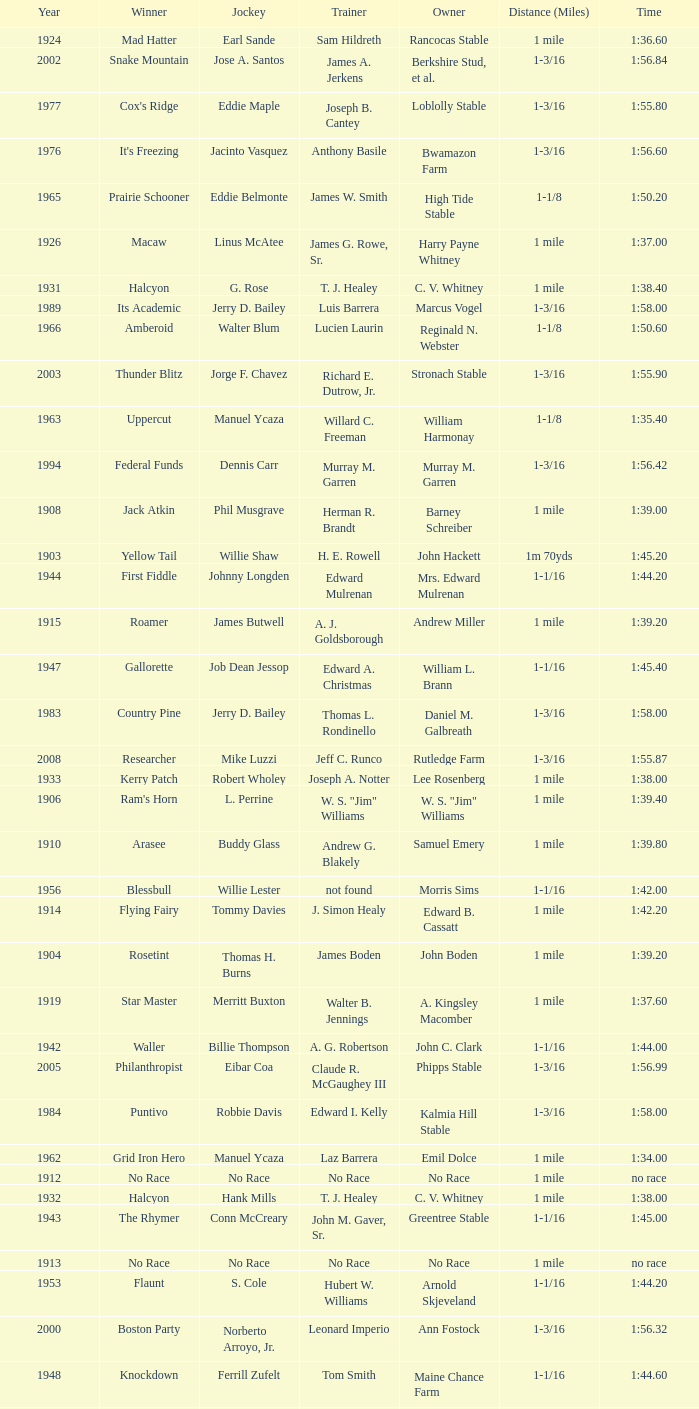Give me the full table as a dictionary. {'header': ['Year', 'Winner', 'Jockey', 'Trainer', 'Owner', 'Distance (Miles)', 'Time'], 'rows': [['1924', 'Mad Hatter', 'Earl Sande', 'Sam Hildreth', 'Rancocas Stable', '1 mile', '1:36.60'], ['2002', 'Snake Mountain', 'Jose A. Santos', 'James A. Jerkens', 'Berkshire Stud, et al.', '1-3/16', '1:56.84'], ['1977', "Cox's Ridge", 'Eddie Maple', 'Joseph B. Cantey', 'Loblolly Stable', '1-3/16', '1:55.80'], ['1976', "It's Freezing", 'Jacinto Vasquez', 'Anthony Basile', 'Bwamazon Farm', '1-3/16', '1:56.60'], ['1965', 'Prairie Schooner', 'Eddie Belmonte', 'James W. Smith', 'High Tide Stable', '1-1/8', '1:50.20'], ['1926', 'Macaw', 'Linus McAtee', 'James G. Rowe, Sr.', 'Harry Payne Whitney', '1 mile', '1:37.00'], ['1931', 'Halcyon', 'G. Rose', 'T. J. Healey', 'C. V. Whitney', '1 mile', '1:38.40'], ['1989', 'Its Academic', 'Jerry D. Bailey', 'Luis Barrera', 'Marcus Vogel', '1-3/16', '1:58.00'], ['1966', 'Amberoid', 'Walter Blum', 'Lucien Laurin', 'Reginald N. Webster', '1-1/8', '1:50.60'], ['2003', 'Thunder Blitz', 'Jorge F. Chavez', 'Richard E. Dutrow, Jr.', 'Stronach Stable', '1-3/16', '1:55.90'], ['1963', 'Uppercut', 'Manuel Ycaza', 'Willard C. Freeman', 'William Harmonay', '1-1/8', '1:35.40'], ['1994', 'Federal Funds', 'Dennis Carr', 'Murray M. Garren', 'Murray M. Garren', '1-3/16', '1:56.42'], ['1908', 'Jack Atkin', 'Phil Musgrave', 'Herman R. Brandt', 'Barney Schreiber', '1 mile', '1:39.00'], ['1903', 'Yellow Tail', 'Willie Shaw', 'H. E. Rowell', 'John Hackett', '1m 70yds', '1:45.20'], ['1944', 'First Fiddle', 'Johnny Longden', 'Edward Mulrenan', 'Mrs. Edward Mulrenan', '1-1/16', '1:44.20'], ['1915', 'Roamer', 'James Butwell', 'A. J. Goldsborough', 'Andrew Miller', '1 mile', '1:39.20'], ['1947', 'Gallorette', 'Job Dean Jessop', 'Edward A. Christmas', 'William L. Brann', '1-1/16', '1:45.40'], ['1983', 'Country Pine', 'Jerry D. Bailey', 'Thomas L. Rondinello', 'Daniel M. Galbreath', '1-3/16', '1:58.00'], ['2008', 'Researcher', 'Mike Luzzi', 'Jeff C. Runco', 'Rutledge Farm', '1-3/16', '1:55.87'], ['1933', 'Kerry Patch', 'Robert Wholey', 'Joseph A. Notter', 'Lee Rosenberg', '1 mile', '1:38.00'], ['1906', "Ram's Horn", 'L. Perrine', 'W. S. "Jim" Williams', 'W. S. "Jim" Williams', '1 mile', '1:39.40'], ['1910', 'Arasee', 'Buddy Glass', 'Andrew G. Blakely', 'Samuel Emery', '1 mile', '1:39.80'], ['1956', 'Blessbull', 'Willie Lester', 'not found', 'Morris Sims', '1-1/16', '1:42.00'], ['1914', 'Flying Fairy', 'Tommy Davies', 'J. Simon Healy', 'Edward B. Cassatt', '1 mile', '1:42.20'], ['1904', 'Rosetint', 'Thomas H. Burns', 'James Boden', 'John Boden', '1 mile', '1:39.20'], ['1919', 'Star Master', 'Merritt Buxton', 'Walter B. Jennings', 'A. Kingsley Macomber', '1 mile', '1:37.60'], ['1942', 'Waller', 'Billie Thompson', 'A. G. Robertson', 'John C. Clark', '1-1/16', '1:44.00'], ['2005', 'Philanthropist', 'Eibar Coa', 'Claude R. McGaughey III', 'Phipps Stable', '1-3/16', '1:56.99'], ['1984', 'Puntivo', 'Robbie Davis', 'Edward I. Kelly', 'Kalmia Hill Stable', '1-3/16', '1:58.00'], ['1962', 'Grid Iron Hero', 'Manuel Ycaza', 'Laz Barrera', 'Emil Dolce', '1 mile', '1:34.00'], ['1912', 'No Race', 'No Race', 'No Race', 'No Race', '1 mile', 'no race'], ['1932', 'Halcyon', 'Hank Mills', 'T. J. Healey', 'C. V. Whitney', '1 mile', '1:38.00'], ['1943', 'The Rhymer', 'Conn McCreary', 'John M. Gaver, Sr.', 'Greentree Stable', '1-1/16', '1:45.00'], ['1913', 'No Race', 'No Race', 'No Race', 'No Race', '1 mile', 'no race'], ['1953', 'Flaunt', 'S. Cole', 'Hubert W. Williams', 'Arnold Skjeveland', '1-1/16', '1:44.20'], ['2000', 'Boston Party', 'Norberto Arroyo, Jr.', 'Leonard Imperio', 'Ann Fostock', '1-3/16', '1:56.32'], ['1948', 'Knockdown', 'Ferrill Zufelt', 'Tom Smith', 'Maine Chance Farm', '1-1/16', '1:44.60'], ['1902', 'Margravite', 'Otto Wonderly', 'not found', 'Charles Fleischmann Sons', '1m 70 yds', '1:46.00'], ['1911', 'No Race', 'No Race', 'No Race', 'No Race', '1 mile', 'no race'], ['1917', 'Old Rosebud', 'Frank Robinson', 'Frank D. Weir', 'F. D. Weir & Hamilton C. Applegate', '1 mile', '1:37.60'], ['1939', 'Lovely Night', 'Johnny Longden', 'Henry McDaniel', 'Mrs. F. Ambrose Clark', '1 mile', '1:36.40'], ['1905', 'St. Valentine', 'William Crimmins', 'John Shields', 'Alexander Shields', '1 mile', '1:39.20'], ['2009', 'Rodman', 'Javier Castellano', 'Michael E. Hushion', 'Barry K. Schwartz', '1-3/16', '1:57.00'], ['1975', 'Hail The Pirates', 'Ron Turcotte', 'Thomas L. Rondinello', 'Daniel M. Galbreath', '1-3/16', '1:55.60'], ['2004', 'Classic Endeavor', 'Aaron Gryder', 'Richard E. Dutrow, Jr.', 'Sullivan Lane, Scuderi', '1-3/16', '1:57.13'], ['1958', 'Oh Johnny', 'William Boland', 'Norman R. McLeod', 'Mrs. Wallace Gilroy', '1-1/16', '1:43.40'], ['1980', "Fool's Prayer", 'Jorge Velasquez', 'Thomas L. Rondinello', 'Darby Dan Farm', '1-3/16', '1:56.00'], ['1981', 'French Cut', 'Don MacBeth', 'Robert DeBonis', 'Gertrude A. Martin', '1-3/16', '1:56.40'], ['1929', 'Comstockery', 'Sidney Hebert', 'Thomas W. Murphy', 'Greentree Stable', '1 mile', '1:39.60'], ['1971', 'Red Reality', 'Jorge Velasquez', 'MacKenzie Miller', 'Cragwood Stables', '1-1/8', '1:49.60'], ['1930', 'Kildare', 'John Passero', 'Norman Tallman', 'Newtondale Stable', '1 mile', '1:38.60'], ['1982', 'Bar Dexter', 'Jeffrey Fell', 'Lou Mondello', 'Woodside Stud', '1-3/16', '1:58.20'], ['1909', 'No Race', 'No Race', 'No Race', 'No Race', '1 mile', 'no race'], ['1918', 'Roamer', 'Lawrence Lyke', 'A. J. Goldsborough', 'Andrew Miller', '1 mile', '1:36.60'], ['2006', 'Magna Graduate', 'John Velazquez', 'Todd Pletcher', 'Elisabeth Alexander', '1-3/16', '1:55.19'], ['1993', 'Repletion', 'Mike E. Smith', 'William I. Mott', 'Bud C. Hatfield', '1-3/16', '1:44.35'], ['1927', 'Light Carbine', 'James McCoy', 'M. J. Dunlevy', 'I. B. Humphreys', '1 mile', '1:36.80'], ['1964', 'Third Martini', 'William Boland', 'H. Allen Jerkens', 'Hobeau Farm', '1-1/8', '1:50.60'], ['1940', 'He Did', 'Eddie Arcaro', 'J. Thomas Taylor', 'W. Arnold Hanger', '1-1/16', '1:43.20'], ['2007', 'Evening Attire', 'Edgar Prado', 'Patrick J. Kelly', 'T. J. Kelly /Joseph & Mary Grant', '1-3/16', '1:58.01'], ['1979', 'Dewan Keys', 'Eddie Maple', 'Philip G. Johnson', 'John E. Morrissey', '1-3/16', '1:56.80'], ['1955', 'Fabulist', 'Ted Atkinson', 'William C. Winfrey', 'High Tide Stable', '1-1/16', '1:43.60'], ['1922', 'Grey Lag', 'Laverne Fator', 'Sam Hildreth', 'Rancocas Stable', '1 mile', '1:38.00'], ['1995', 'Aztec Empire', 'Jean-Luc Saymn', 'H. Allen Jerkens', 'Hobeau Farm', '1-3/16', '1:55.56'], ['1951', 'Sheilas Reward', 'Ovie Scurlock', 'Eugene Jacobs', 'Mrs. Louis Lazare', '1-1/16', '1:44.60'], ['1987', 'Personal Flag', 'Randy Romero', 'Claude R. McGaughey III', 'Ogden Phipps', '1-3/16', '1:59.00'], ['1968', 'Irish Dude', 'Sandino Hernandez', 'Jack Bradley', 'Richard W. Taylor', '1-1/8', '1:49.60'], ['1970', 'Best Turn', 'Larry Adams', 'Reggie Cornell', 'Calumet Farm', '1-1/8', '1:50.00'], ['1996', 'Topsy Robsy', 'Paula-Keim Bruno', 'H. Allen Jerkens', 'Hobeau Farm', '1-3/16', '1:55.30'], ['1973', 'True Knight', 'Angel Cordero, Jr.', 'Thomas L. Rondinello', 'Darby Dan Farm', '1-3/16', '1:55.00'], ['1997', 'Mr. Sinatra', 'Richard Migliore', 'Gasper Moschera', 'Barbara J. Davis', '1-3/16', '1:55.68'], ['1928', 'Kentucky II', 'George Schreiner', 'Max Hirsch', 'A. Charles Schwartz', '1 mile', '1:38.80'], ['1916', 'Short Grass', 'Frank Keogh', 'not found', 'Emil Herz', '1 mile', '1:36.40'], ['1991', 'Nome', 'Eddie Maple', 'Peter Ferriola', 'James Riccio', '1-3/16', '1:56.00'], ['1934', 'Singing Wood', 'Robert Jones', 'James W. Healy', 'Liz Whitney', '1 mile', '1:38.60'], ['1945', 'Olympic Zenith', 'Conn McCreary', 'Willie Booth', 'William G. Helis', '1-1/16', '1:45.60'], ['1978', 'Cum Laude Laurie', 'Angel Cordero, Jr.', 'Thomas L. Rondinello', 'Daniel M. Galbreath', '1-3/16', '1:55.80'], ['1941', 'Salford II', 'Don Meade', 'not found', 'Ralph B. Strassburger', '1-1/16', '1:44.20'], ['1938', 'War Admiral', 'Charles Kurtsinger', 'George Conway', 'Glen Riddle Farm', '1 mile', '1:36.80'], ['1961', 'Manassa Mauler', 'Braulio Baeza', 'Pancho Martin', 'Emil Dolce', '1 mile', '1:36.20'], ['1972', 'Sunny And Mild', 'Michael Venezia', 'W. Preston King', 'Harry Rogosin', '1-3/16', '1:54.40'], ['1952', 'County Delight', 'Dave Gorman', 'James E. Ryan', 'Rokeby Stable', '1-1/16', '1:43.60'], ['1923', 'Zev', 'Earl Sande', 'Sam Hildreth', 'Rancocas Stable', '1 mile', '1:37.00'], ['1990', 'Sport View', 'Craig Perret', 'D. Wayne Lukas', 'Edward A. Cox, Jr.', '1-3/16', '1:57.00'], ['1935', 'King Saxon', 'Calvin Rainey', 'Charles Shaw', 'C. H. Knebelkamp', '1 mile', '1:37.20'], ['1988', 'Lay Down', 'Jean-Luc Samyn', 'Claude R. McGaughey III', 'Ogden Mills Phipps', '1-3/16', '1:57.20'], ['1986', 'Pine Belt', 'Eddie Maple', 'George R. Arnold II', 'Loblolly Stable', '1-3/16', '1:57.20'], ['1985', 'Late Act', 'Eddie Maple', 'Robert Reinacher', 'Greentree Stable', '1-3/16', '1:55.80'], ['1920', 'Cirrus', 'Lavelle Ensor', 'Sam Hildreth', 'Sam Hildreth', '1 mile', '1:38.00'], ['1907', 'W. H. Carey', 'George Mountain', 'James Blute', 'Richard F. Carman', '1 mile', '1:40.00'], ['1959', 'Whitley', 'Eric Guerin', 'Max Hirsch', 'W. Arnold Hanger', '1 mile', '1:36.40'], ['1999', 'Early Warning', 'Jorge F. Chavez', 'Todd Pletcher', 'Dogwood Stable', '1-3/16', '1:55.03'], ['2010', 'More Than a Reason', 'Eddie Castro', 'Randy Persaud', 'Anthony Calabrese', '1-3/16', '1:57.69'], ['1937', 'Snark', 'Johnny Longden', 'James E. Fitzsimmons', 'Wheatley Stable', '1 mile', '1:37.40'], ['1998', 'Fire King', 'Frank Lovato, Jr.', 'Michael E. Hushion', 'Schwartz & Hauman', '1-3/16', '1:56.88'], ['1921', 'John P. Grier', 'Frank Keogh', 'James G. Rowe, Sr.', 'Harry Payne Whitney', '1 mile', '1:36.00'], ['1925', 'Mad Play', 'Laverne Fator', 'Sam Hildreth', 'Rancocas Stable', '1 mile', '1:36.60'], ['2001', 'Evening Attire', 'Shaun Bridgmohan', 'Patrick J. Kelly', 'Mary Grant', '1-3/16', '1:55.08'], ['1946', 'Helioptic', 'Paul Miller', 'not found', 'William Goadby Loew', '1-1/16', '1:43.20'], ['1954', 'Find', 'Eric Guerin', 'William C. Winfrey', 'Alfred G. Vanderbilt II', '1-1/16', '1:44.00'], ['1967', 'Mr. Right', 'Heliodoro Gustines', 'Evan S. Jackson', 'Mrs. Peter Duchin', '1-1/8', '1:49.60'], ['1974', 'Free Hand', 'Jose Amy', 'Pancho Martin', 'Sigmund Sommer', '1-3/16', '1:55.00'], ['1992', 'Shots Are Ringing', 'John Velazquez', 'Peter Ferriola', 'Jewel E. Stable', '1-3/16', '1:54.90'], ['1960', 'Cranberry Sauce', 'Heliodoro Gustines', 'not found', 'Elmendorf Farm', '1 mile', '1:36.20'], ['1936', 'Good Gamble', 'Samuel Renick', 'Bud Stotler', 'Alfred G. Vanderbilt II', '1 mile', '1:37.20'], ['1957', 'Bold Ruler', 'Eddie Arcaro', 'James E. Fitzsimmons', 'Wheatley Stable', '1-1/16', '1:42.80'], ['1950', 'Three Rings', 'Hedley Woodhouse', 'Willie Knapp', 'Mrs. Evelyn L. Hopkins', '1-1/16', '1:44.60'], ['1969', 'Vif', 'Larry Adams', 'Clarence Meaux', 'Harvey Peltier', '1-1/8', '1:49.20'], ['1949', 'Three Rings', 'Ted Atkinson', 'Willie Knapp', 'Mrs. Evelyn L. Hopkins', '1-1/16', '1:47.40']]} What horse won with a trainer of "no race"? No Race, No Race, No Race, No Race. 